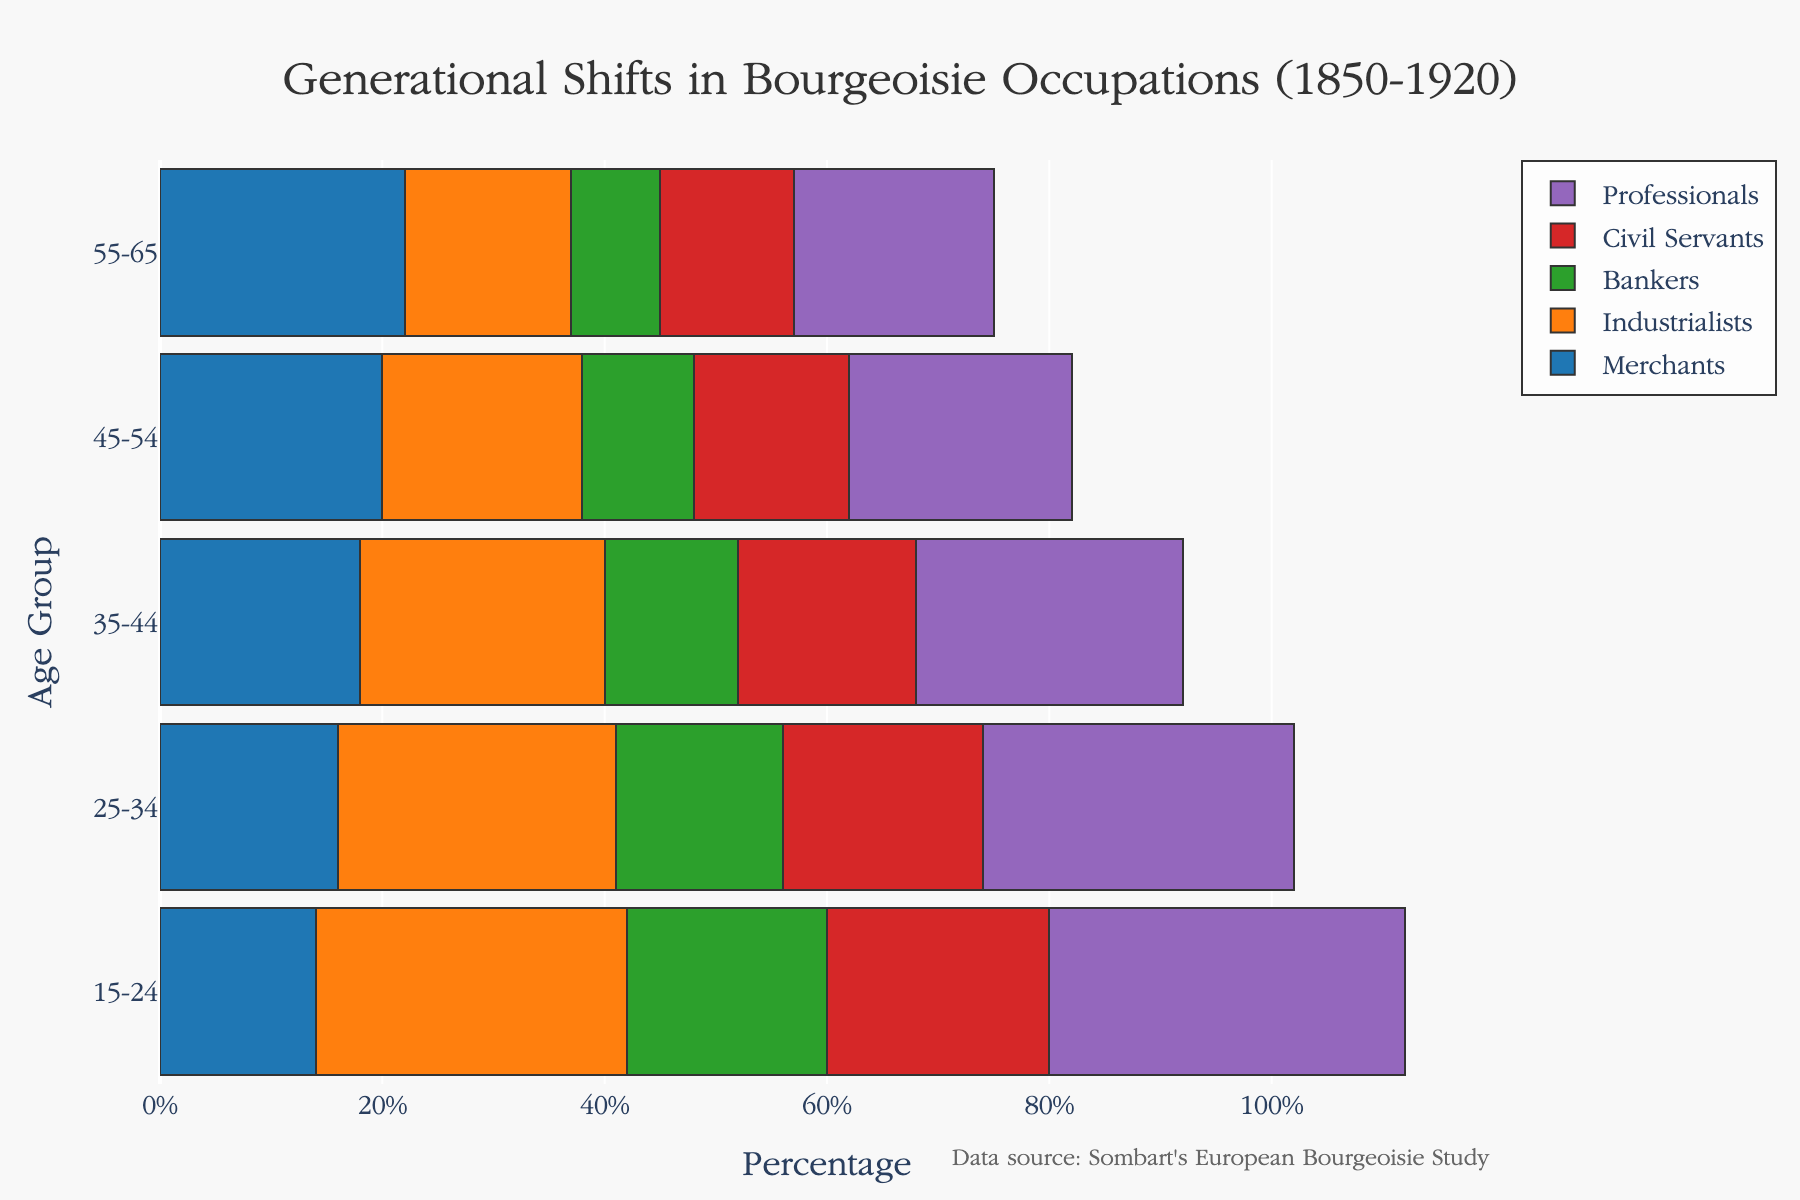What's the title of the figure? The title is usually located at the top of the plot, providing an overview of the content displayed.
Answer: Generational Shifts in Bourgeoisie Occupations (1850-1920) What is the age group with the highest percentage of Professional occupations? By inspecting the bars representing the Professional occupations, you can see that the longest bar corresponding to the Professional category belongs to a specific age group.
Answer: 15-24 Which occupational category shows a consistent increase across all age groups? By analyzing the trends of the different categories from older to younger age groups, you can determine which one has a steadily increasing number.
Answer: Industrialists How many age groups are represented in the figure? Look at the y-axis to count the distinct age groups displayed in the plot.
Answer: 5 Compare the percentage of Industrialists in the 45-54 age group to that in the 25-34 age group. Identify and compare the bar lengths for Industrialists within the 45-54 and 25-34 age groups.
Answer: The percentage of Industrialists in 25-34 is 7% higher than in 45-54 What is the percentage difference in Bankers between the 15-24 and 55-65 age groups? Subtract the percentage of Bankers in 55-65 from that in 15-24 to get the difference.
Answer: 10% Which category has the lowest percentage in the 25-34 age group? Inspect the bars for the 25-34 age group to identify which category bar is the shortest.
Answer: Merchants Sum the percentages of Civil Servants in the 35-44 and 45-54 age groups. Add the values of Civil Servants in the 35-44 and 45-54 age groups by referencing their bar lengths respectively.
Answer: 30% What color represents the Bankers category, and what is the range of percentages for Bankers across age groups? Observe the colors used in the plot legend to identify the Bankers category, then check the bar lengths for the range of percentages.
Answer: Green; Range is 8% to 18% Are there any age groups where Civil Servants make up an equal percentage as in another age group? Compare the bar lengths for Civil Servants across age groups to determine if any match exactly.
Answer: No 